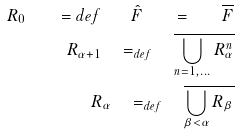<formula> <loc_0><loc_0><loc_500><loc_500>R _ { 0 } \quad = { d e f } \quad \hat { F } \quad = \quad \overline { F } \\ R _ { \alpha + 1 } \quad = _ { d e f } \quad \overline { \bigcup _ { n = 1 , \dots } R _ { \alpha } ^ { n } } \\ R _ { \alpha } \quad = _ { d e f } \quad \overline { \bigcup _ { \beta < \alpha } R _ { \beta } }</formula> 